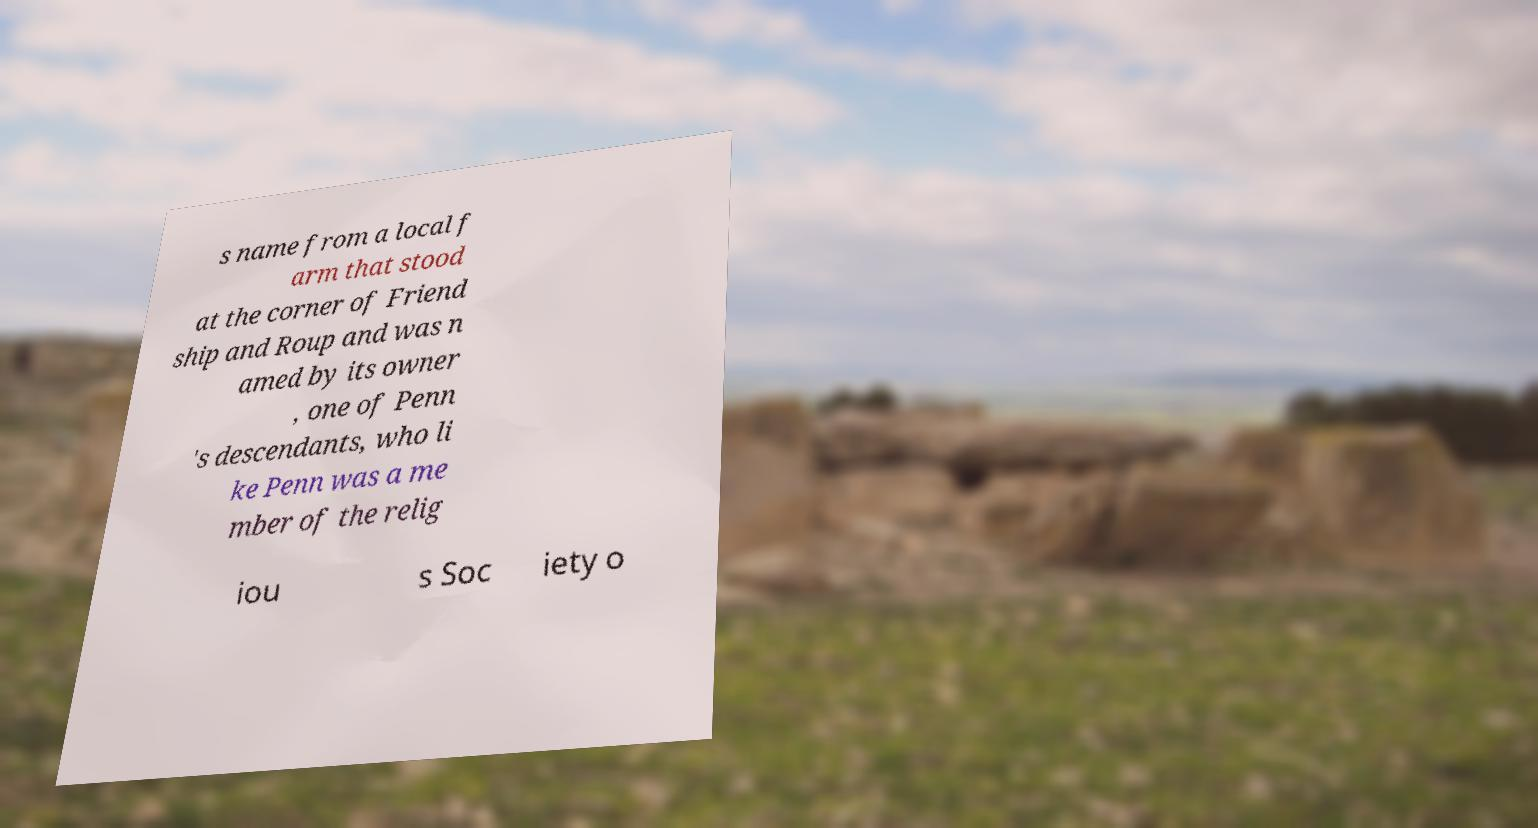What messages or text are displayed in this image? I need them in a readable, typed format. s name from a local f arm that stood at the corner of Friend ship and Roup and was n amed by its owner , one of Penn 's descendants, who li ke Penn was a me mber of the relig iou s Soc iety o 